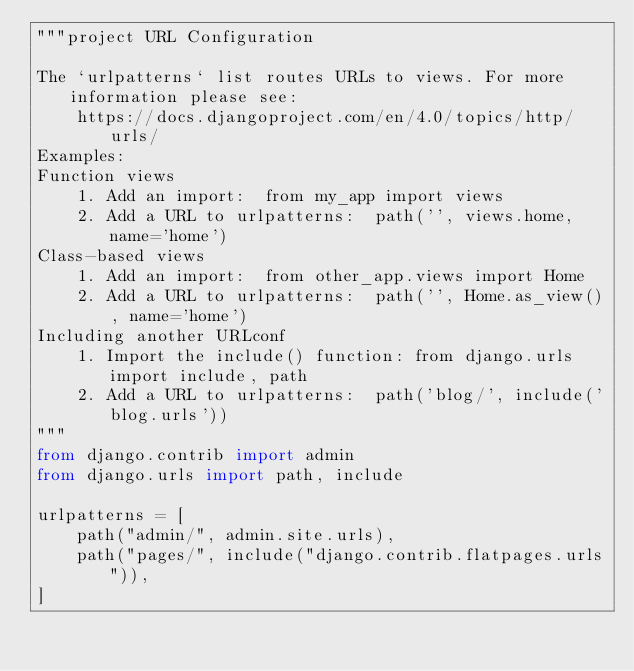<code> <loc_0><loc_0><loc_500><loc_500><_Python_>"""project URL Configuration

The `urlpatterns` list routes URLs to views. For more information please see:
    https://docs.djangoproject.com/en/4.0/topics/http/urls/
Examples:
Function views
    1. Add an import:  from my_app import views
    2. Add a URL to urlpatterns:  path('', views.home, name='home')
Class-based views
    1. Add an import:  from other_app.views import Home
    2. Add a URL to urlpatterns:  path('', Home.as_view(), name='home')
Including another URLconf
    1. Import the include() function: from django.urls import include, path
    2. Add a URL to urlpatterns:  path('blog/', include('blog.urls'))
"""
from django.contrib import admin
from django.urls import path, include

urlpatterns = [
    path("admin/", admin.site.urls),
    path("pages/", include("django.contrib.flatpages.urls")),
]
</code> 